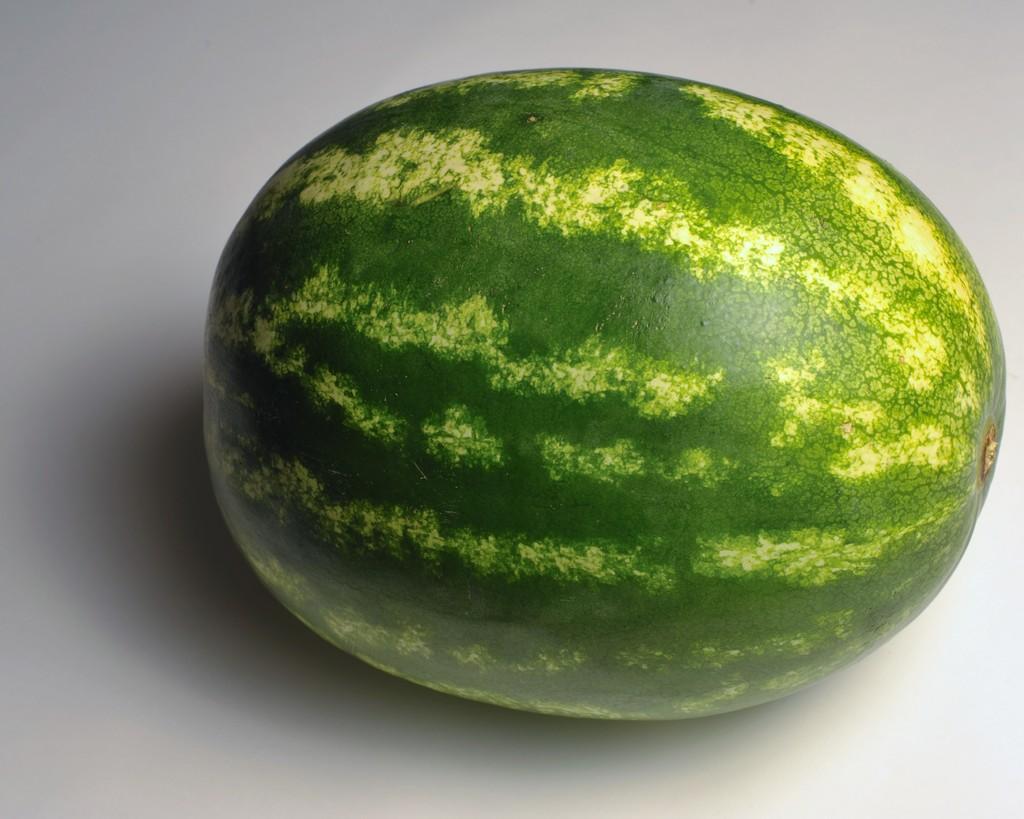In one or two sentences, can you explain what this image depicts? In this image I can see a watermelon which is green and yellow in color. I can see the white colored background. 